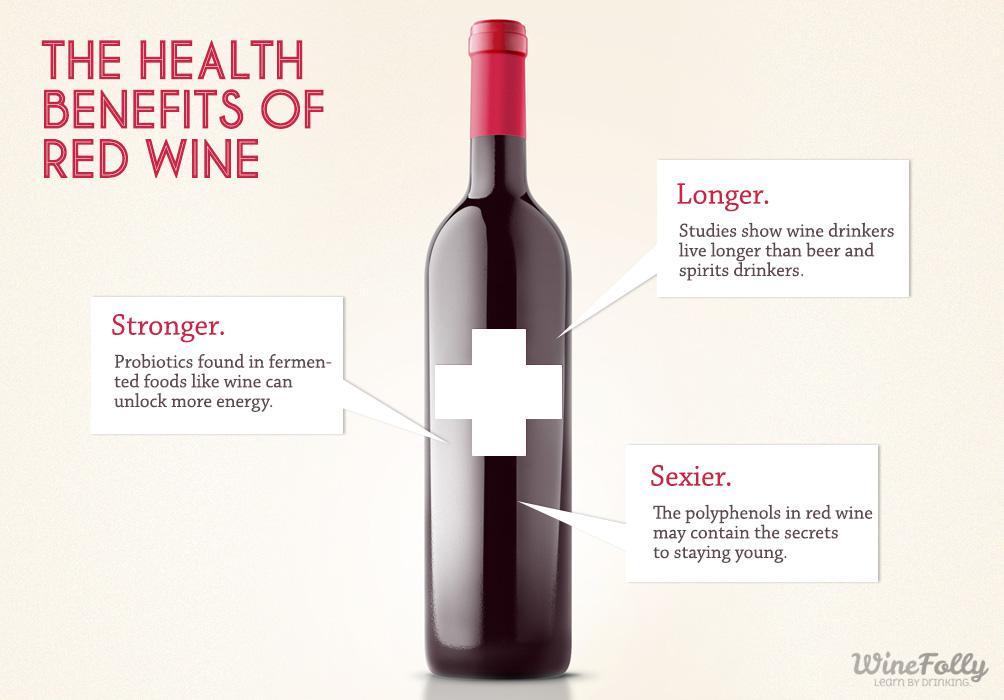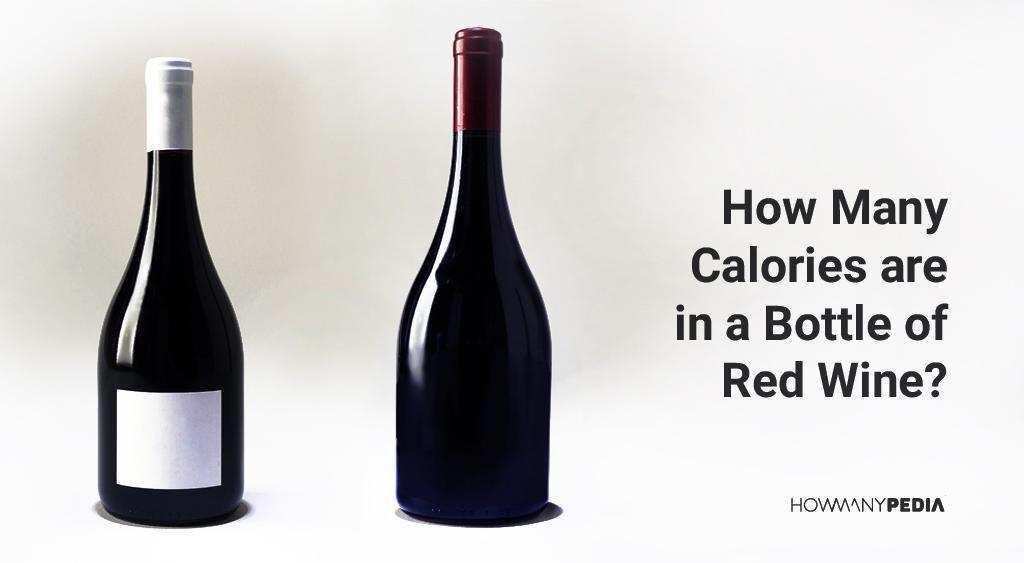The first image is the image on the left, the second image is the image on the right. Evaluate the accuracy of this statement regarding the images: "Images show a total of three wine bottles.". Is it true? Answer yes or no. Yes. 